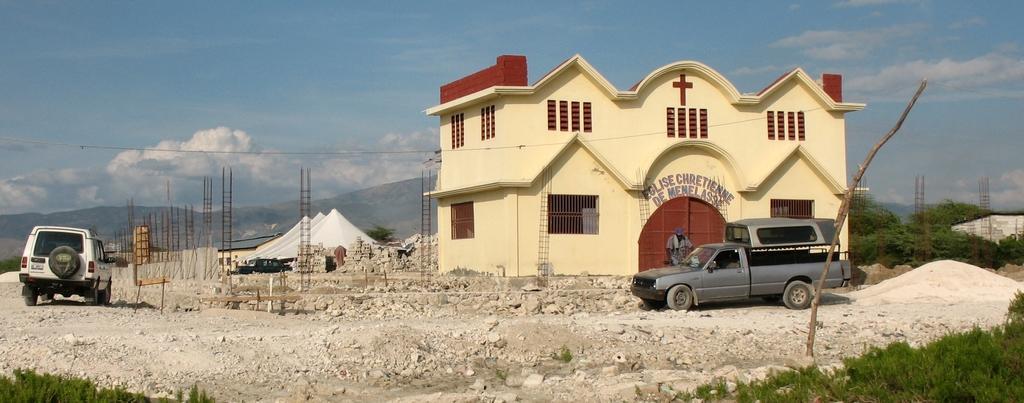Can you describe this image briefly? This is an outside view. On the right side there is a building. In front of this building there is a vehicle and a person is standing. In the background there are few trees. On the left side there is a car on the ground. In the background there are few tents and also I can see few metal poles. At the bottom, I can see the grass. At the top of the image I can see the sky and clouds. 